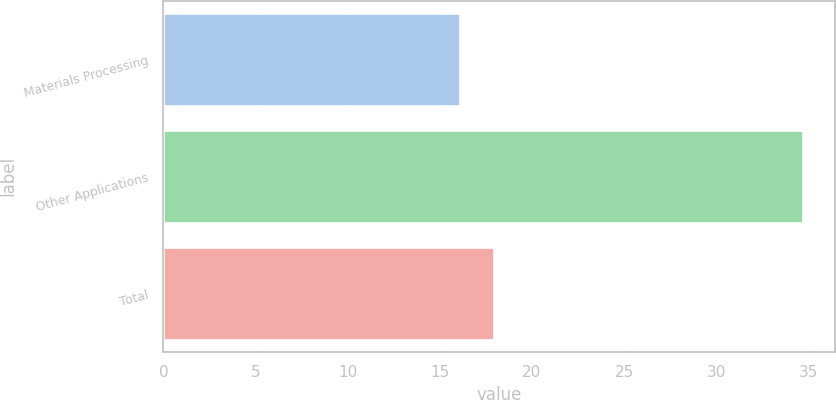Convert chart to OTSL. <chart><loc_0><loc_0><loc_500><loc_500><bar_chart><fcel>Materials Processing<fcel>Other Applications<fcel>Total<nl><fcel>16.1<fcel>34.7<fcel>17.96<nl></chart> 